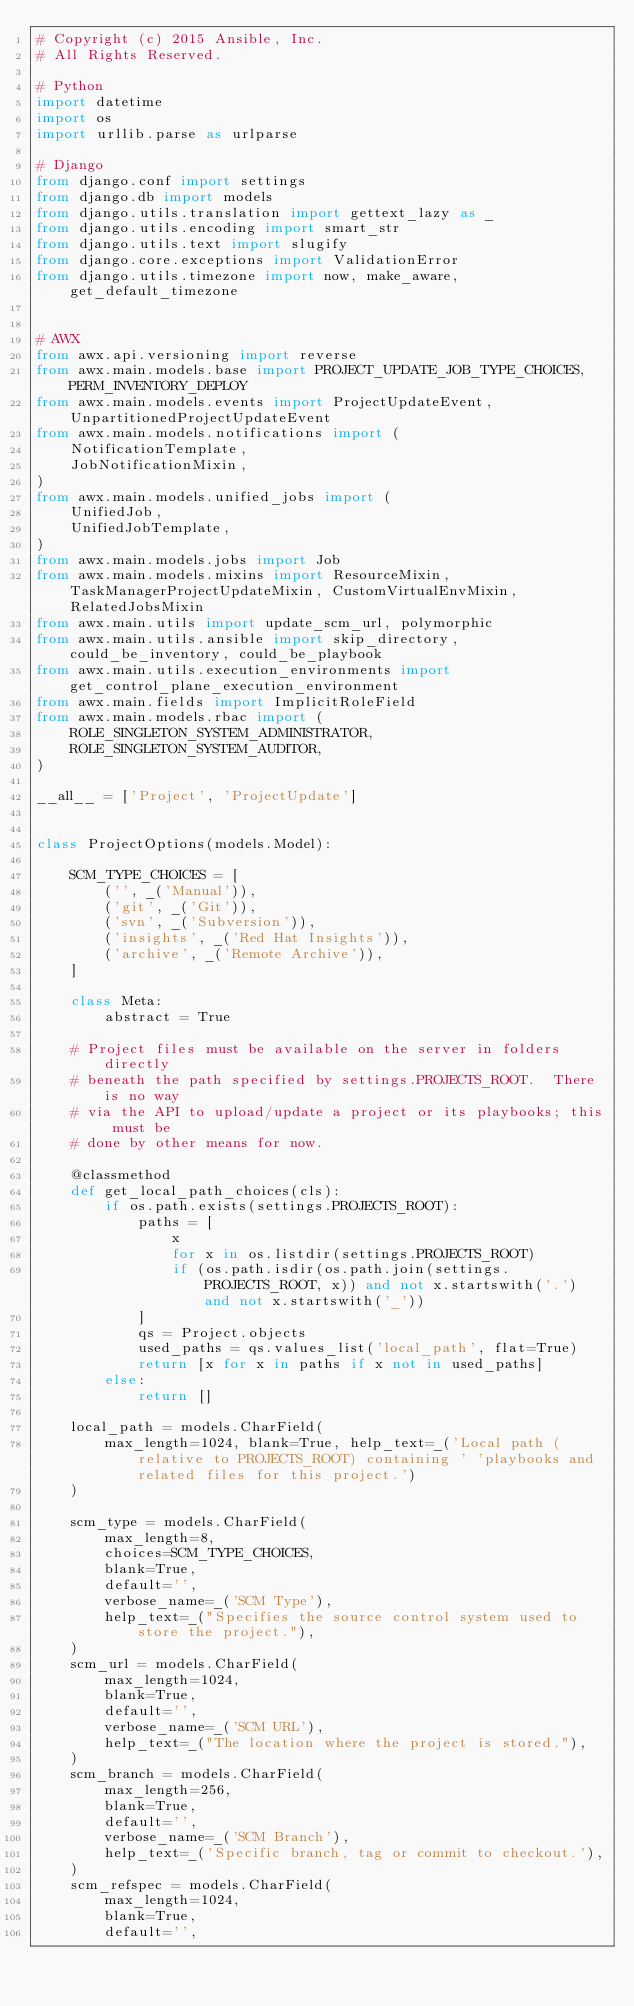<code> <loc_0><loc_0><loc_500><loc_500><_Python_># Copyright (c) 2015 Ansible, Inc.
# All Rights Reserved.

# Python
import datetime
import os
import urllib.parse as urlparse

# Django
from django.conf import settings
from django.db import models
from django.utils.translation import gettext_lazy as _
from django.utils.encoding import smart_str
from django.utils.text import slugify
from django.core.exceptions import ValidationError
from django.utils.timezone import now, make_aware, get_default_timezone


# AWX
from awx.api.versioning import reverse
from awx.main.models.base import PROJECT_UPDATE_JOB_TYPE_CHOICES, PERM_INVENTORY_DEPLOY
from awx.main.models.events import ProjectUpdateEvent, UnpartitionedProjectUpdateEvent
from awx.main.models.notifications import (
    NotificationTemplate,
    JobNotificationMixin,
)
from awx.main.models.unified_jobs import (
    UnifiedJob,
    UnifiedJobTemplate,
)
from awx.main.models.jobs import Job
from awx.main.models.mixins import ResourceMixin, TaskManagerProjectUpdateMixin, CustomVirtualEnvMixin, RelatedJobsMixin
from awx.main.utils import update_scm_url, polymorphic
from awx.main.utils.ansible import skip_directory, could_be_inventory, could_be_playbook
from awx.main.utils.execution_environments import get_control_plane_execution_environment
from awx.main.fields import ImplicitRoleField
from awx.main.models.rbac import (
    ROLE_SINGLETON_SYSTEM_ADMINISTRATOR,
    ROLE_SINGLETON_SYSTEM_AUDITOR,
)

__all__ = ['Project', 'ProjectUpdate']


class ProjectOptions(models.Model):

    SCM_TYPE_CHOICES = [
        ('', _('Manual')),
        ('git', _('Git')),
        ('svn', _('Subversion')),
        ('insights', _('Red Hat Insights')),
        ('archive', _('Remote Archive')),
    ]

    class Meta:
        abstract = True

    # Project files must be available on the server in folders directly
    # beneath the path specified by settings.PROJECTS_ROOT.  There is no way
    # via the API to upload/update a project or its playbooks; this must be
    # done by other means for now.

    @classmethod
    def get_local_path_choices(cls):
        if os.path.exists(settings.PROJECTS_ROOT):
            paths = [
                x
                for x in os.listdir(settings.PROJECTS_ROOT)
                if (os.path.isdir(os.path.join(settings.PROJECTS_ROOT, x)) and not x.startswith('.') and not x.startswith('_'))
            ]
            qs = Project.objects
            used_paths = qs.values_list('local_path', flat=True)
            return [x for x in paths if x not in used_paths]
        else:
            return []

    local_path = models.CharField(
        max_length=1024, blank=True, help_text=_('Local path (relative to PROJECTS_ROOT) containing ' 'playbooks and related files for this project.')
    )

    scm_type = models.CharField(
        max_length=8,
        choices=SCM_TYPE_CHOICES,
        blank=True,
        default='',
        verbose_name=_('SCM Type'),
        help_text=_("Specifies the source control system used to store the project."),
    )
    scm_url = models.CharField(
        max_length=1024,
        blank=True,
        default='',
        verbose_name=_('SCM URL'),
        help_text=_("The location where the project is stored."),
    )
    scm_branch = models.CharField(
        max_length=256,
        blank=True,
        default='',
        verbose_name=_('SCM Branch'),
        help_text=_('Specific branch, tag or commit to checkout.'),
    )
    scm_refspec = models.CharField(
        max_length=1024,
        blank=True,
        default='',</code> 